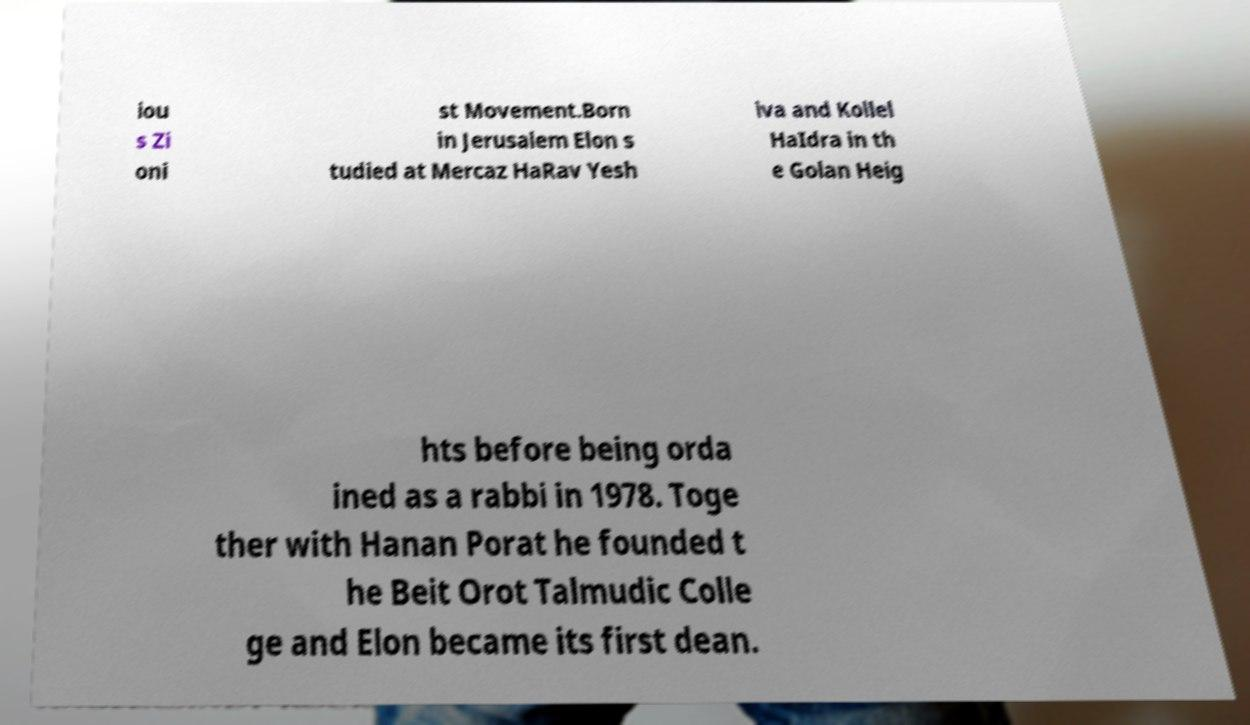Can you accurately transcribe the text from the provided image for me? iou s Zi oni st Movement.Born in Jerusalem Elon s tudied at Mercaz HaRav Yesh iva and Kollel HaIdra in th e Golan Heig hts before being orda ined as a rabbi in 1978. Toge ther with Hanan Porat he founded t he Beit Orot Talmudic Colle ge and Elon became its first dean. 